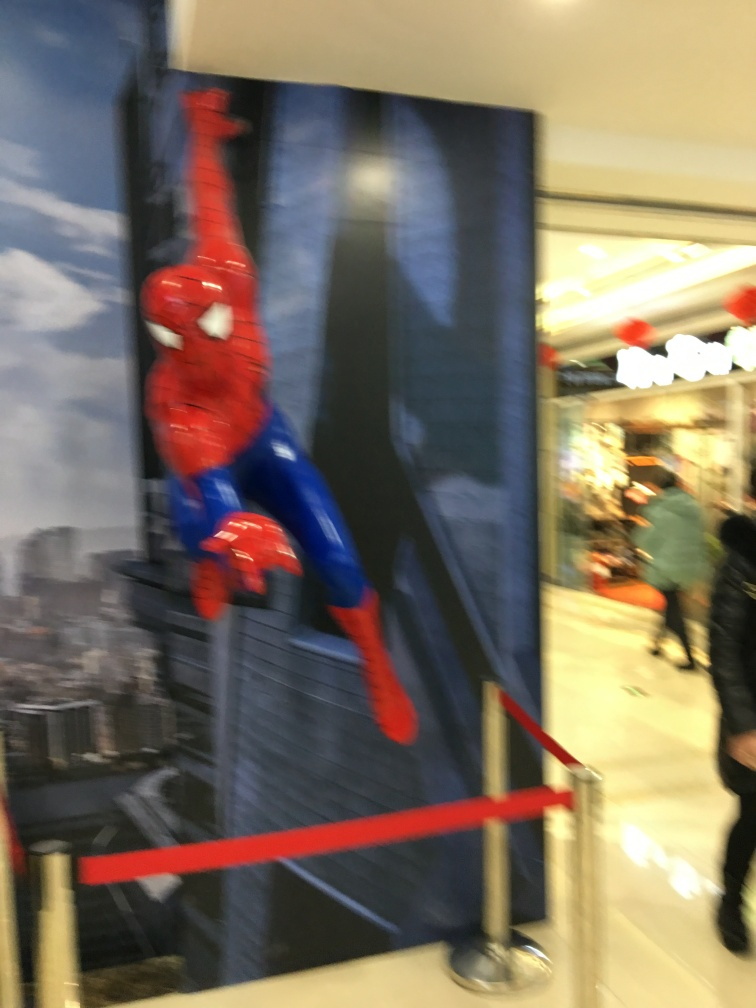Can you describe any specific details or elements that stand out in this image? Certainly! The most striking element is the figure in a superhero costume, specifically Spider-Man, clinging to a vertical surface, which evokes feelings of action and adventure. Additionally, the use of ropes to create a perimeter around the display adds a layer of reality, indicating this is an exhibit or event. 